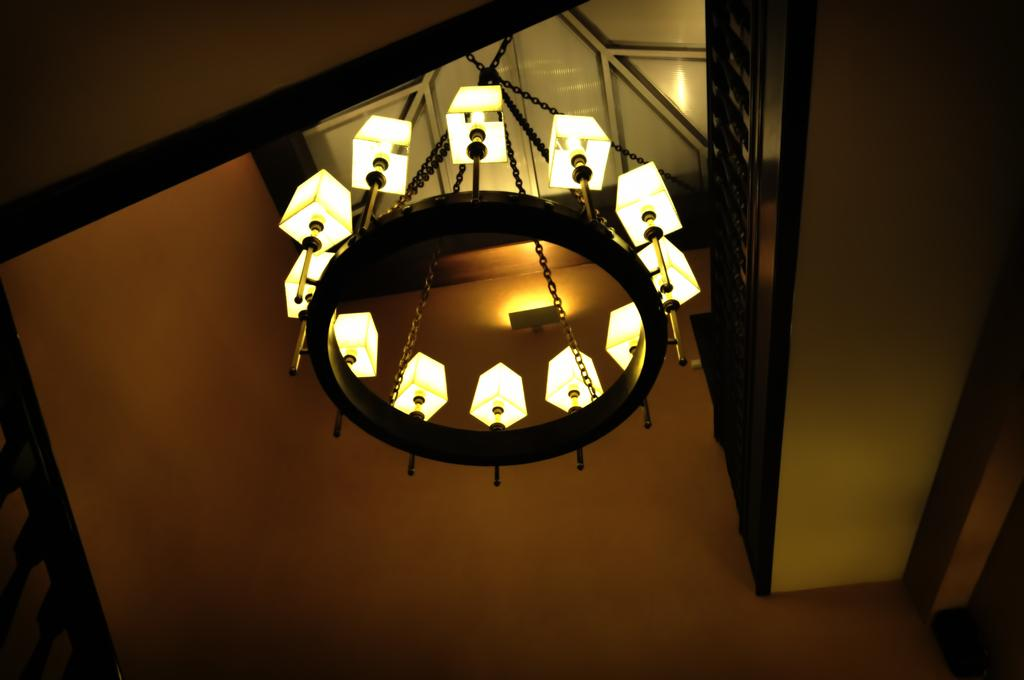What part of the room can be seen at the top of the image? The ceiling is visible in the image. What type of lighting fixture is present in the image? There is a chandelier in the image. What part of the room can be seen on the sides of the image? The wall is visible in the image. What type of science experiment is being conducted in the image? There is no science experiment present in the image; it only features a ceiling, a chandelier, and a wall. How many chairs are visible in the image? There are no chairs visible in the image. 